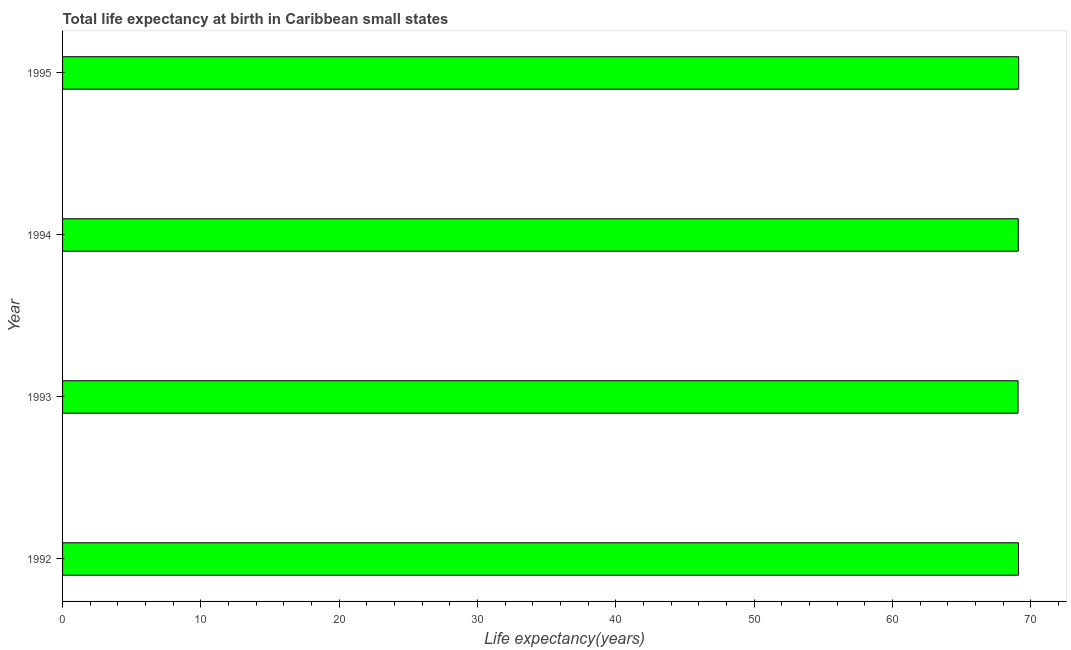What is the title of the graph?
Provide a short and direct response. Total life expectancy at birth in Caribbean small states. What is the label or title of the X-axis?
Your answer should be very brief. Life expectancy(years). What is the life expectancy at birth in 1992?
Your response must be concise. 69.11. Across all years, what is the maximum life expectancy at birth?
Keep it short and to the point. 69.12. Across all years, what is the minimum life expectancy at birth?
Keep it short and to the point. 69.08. What is the sum of the life expectancy at birth?
Keep it short and to the point. 276.4. What is the difference between the life expectancy at birth in 1992 and 1993?
Provide a short and direct response. 0.03. What is the average life expectancy at birth per year?
Provide a short and direct response. 69.1. What is the median life expectancy at birth?
Offer a terse response. 69.1. In how many years, is the life expectancy at birth greater than 58 years?
Offer a very short reply. 4. Is the life expectancy at birth in 1992 less than that in 1995?
Your response must be concise. Yes. What is the difference between the highest and the second highest life expectancy at birth?
Your answer should be compact. 0.01. Is the sum of the life expectancy at birth in 1994 and 1995 greater than the maximum life expectancy at birth across all years?
Make the answer very short. Yes. What is the difference between the highest and the lowest life expectancy at birth?
Your answer should be very brief. 0.05. In how many years, is the life expectancy at birth greater than the average life expectancy at birth taken over all years?
Offer a terse response. 2. How many bars are there?
Provide a short and direct response. 4. Are the values on the major ticks of X-axis written in scientific E-notation?
Provide a short and direct response. No. What is the Life expectancy(years) in 1992?
Your answer should be compact. 69.11. What is the Life expectancy(years) in 1993?
Provide a short and direct response. 69.08. What is the Life expectancy(years) in 1994?
Give a very brief answer. 69.1. What is the Life expectancy(years) in 1995?
Your response must be concise. 69.12. What is the difference between the Life expectancy(years) in 1992 and 1993?
Give a very brief answer. 0.03. What is the difference between the Life expectancy(years) in 1992 and 1994?
Offer a very short reply. 0.01. What is the difference between the Life expectancy(years) in 1992 and 1995?
Ensure brevity in your answer.  -0.01. What is the difference between the Life expectancy(years) in 1993 and 1994?
Make the answer very short. -0.02. What is the difference between the Life expectancy(years) in 1993 and 1995?
Your answer should be very brief. -0.05. What is the difference between the Life expectancy(years) in 1994 and 1995?
Keep it short and to the point. -0.03. What is the ratio of the Life expectancy(years) in 1992 to that in 1995?
Ensure brevity in your answer.  1. What is the ratio of the Life expectancy(years) in 1993 to that in 1994?
Your answer should be very brief. 1. What is the ratio of the Life expectancy(years) in 1993 to that in 1995?
Keep it short and to the point. 1. 